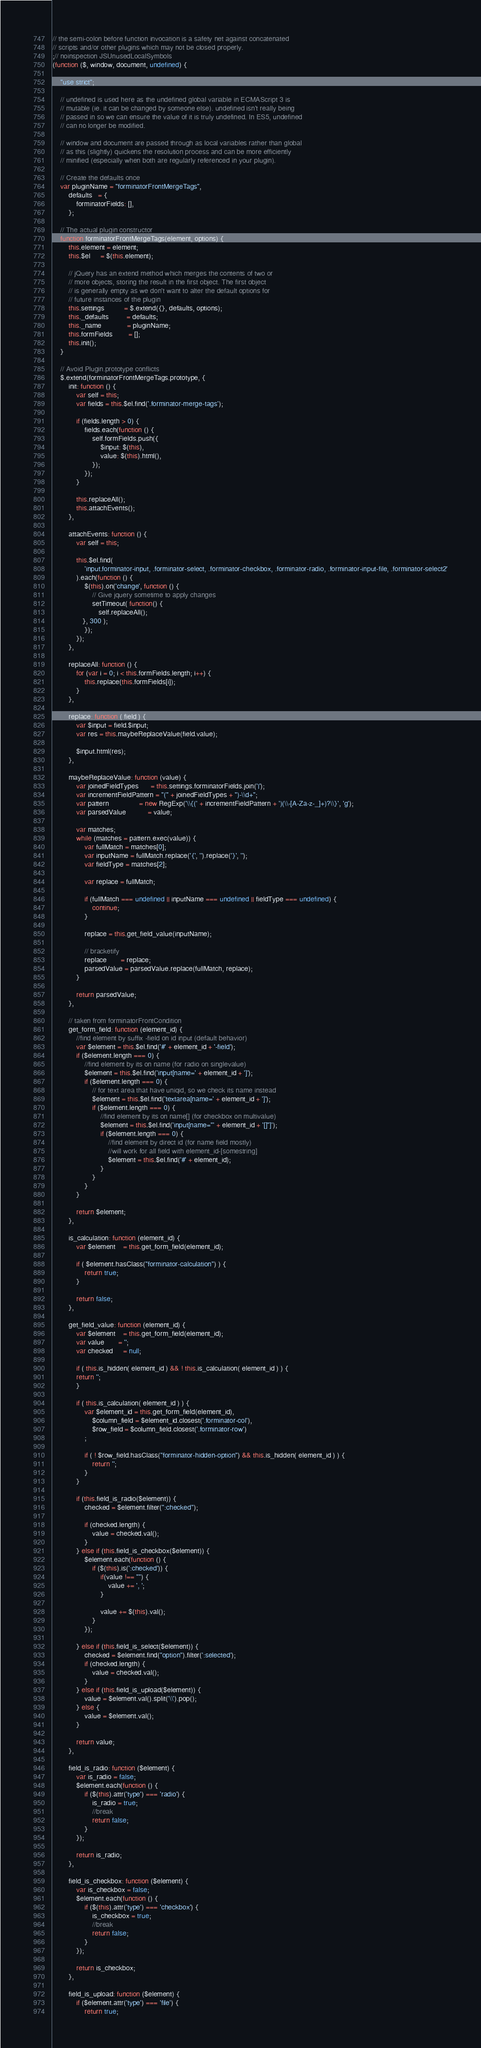Convert code to text. <code><loc_0><loc_0><loc_500><loc_500><_JavaScript_>// the semi-colon before function invocation is a safety net against concatenated
// scripts and/or other plugins which may not be closed properly.
;// noinspection JSUnusedLocalSymbols
(function ($, window, document, undefined) {

	"use strict";

	// undefined is used here as the undefined global variable in ECMAScript 3 is
	// mutable (ie. it can be changed by someone else). undefined isn't really being
	// passed in so we can ensure the value of it is truly undefined. In ES5, undefined
	// can no longer be modified.

	// window and document are passed through as local variables rather than global
	// as this (slightly) quickens the resolution process and can be more efficiently
	// minified (especially when both are regularly referenced in your plugin).

	// Create the defaults once
	var pluginName = "forminatorFrontMergeTags",
	    defaults   = {
		    forminatorFields: [],
	    };

	// The actual plugin constructor
	function forminatorFrontMergeTags(element, options) {
		this.element = element;
		this.$el     = $(this.element);

		// jQuery has an extend method which merges the contents of two or
		// more objects, storing the result in the first object. The first object
		// is generally empty as we don't want to alter the default options for
		// future instances of the plugin
		this.settings          = $.extend({}, defaults, options);
		this._defaults         = defaults;
		this._name             = pluginName;
		this.formFields        = [];
		this.init();
	}

	// Avoid Plugin.prototype conflicts
	$.extend(forminatorFrontMergeTags.prototype, {
		init: function () {
			var self = this;
			var fields = this.$el.find('.forminator-merge-tags');

			if (fields.length > 0) {
				fields.each(function () {
					self.formFields.push({
						$input: $(this),
						value: $(this).html(),
					});
				});
			}

			this.replaceAll();
			this.attachEvents();
		},

		attachEvents: function () {
			var self = this;

			this.$el.find(
				'input.forminator-input, .forminator-select, .forminator-checkbox, .forminator-radio, .forminator-input-file, .forminator-select2'
			).each(function () {
				$(this).on('change', function () {
					// Give jquery sometime to apply changes
					setTimeout( function() {
					   self.replaceAll();
               }, 300 );
				});
			});
		},

		replaceAll: function () {
			for (var i = 0; i < this.formFields.length; i++) {
				this.replace(this.formFields[i]);
			}
		},

		replace: function ( field ) {
			var $input = field.$input;
			var res = this.maybeReplaceValue(field.value);

			$input.html(res);
		},

		maybeReplaceValue: function (value) {
			var joinedFieldTypes      = this.settings.forminatorFields.join('|');
			var incrementFieldPattern = "(" + joinedFieldTypes + ")-\\d+";
			var pattern               = new RegExp('\\{(' + incrementFieldPattern + ')(\\-[A-Za-z-_]+)?\\}', 'g');
			var parsedValue           = value;

			var matches;
			while (matches = pattern.exec(value)) {
				var fullMatch = matches[0];
				var inputName = fullMatch.replace('{', '').replace('}', '');
				var fieldType = matches[2];

				var replace = fullMatch;

				if (fullMatch === undefined || inputName === undefined || fieldType === undefined) {
					continue;
				}

				replace = this.get_field_value(inputName);

				// bracketify
				replace       = replace;
				parsedValue = parsedValue.replace(fullMatch, replace);
			}

			return parsedValue;
		},

		// taken from forminatorFrontCondition
		get_form_field: function (element_id) {
			//find element by suffix -field on id input (default behavior)
			var $element = this.$el.find('#' + element_id + '-field');
			if ($element.length === 0) {
				//find element by its on name (for radio on singlevalue)
				$element = this.$el.find('input[name=' + element_id + ']');
				if ($element.length === 0) {
					// for text area that have uniqid, so we check its name instead
					$element = this.$el.find('textarea[name=' + element_id + ']');
					if ($element.length === 0) {
						//find element by its on name[] (for checkbox on multivalue)
						$element = this.$el.find('input[name="' + element_id + '[]"]');
						if ($element.length === 0) {
							//find element by direct id (for name field mostly)
							//will work for all field with element_id-[somestring]
							$element = this.$el.find('#' + element_id);
						}
					}
				}
			}

			return $element;
		},

		is_calculation: function (element_id) {
			var $element    = this.get_form_field(element_id);

			if ( $element.hasClass("forminator-calculation") ) {
				return true;
			}

			return false;
		},

		get_field_value: function (element_id) {
			var $element    = this.get_form_field(element_id);
			var value       = '';
			var checked     = null;

			if ( this.is_hidden( element_id ) && ! this.is_calculation( element_id ) ) {
         	return '';
			}

			if ( this.is_calculation( element_id ) ) {
				var $element_id = this.get_form_field(element_id),
					$column_field = $element_id.closest('.forminator-col'),
					$row_field = $column_field.closest('.forminator-row')
				;

				if ( ! $row_field.hasClass("forminator-hidden-option") && this.is_hidden( element_id ) ) {
					return '';
				}
			}

			if (this.field_is_radio($element)) {
				checked = $element.filter(":checked");

				if (checked.length) {
					value = checked.val();
				}
			} else if (this.field_is_checkbox($element)) {
				$element.each(function () {
					if ($(this).is(':checked')) {
						if(value !== "") {
							value += ', ';
						}

						value += $(this).val();
					}
				});

			} else if (this.field_is_select($element)) {
				checked = $element.find("option").filter(':selected');
				if (checked.length) {
					value = checked.val();
				}
			} else if (this.field_is_upload($element)) {
				value = $element.val().split('\\').pop();
			} else {
				value = $element.val();
			}

			return value;
		},

		field_is_radio: function ($element) {
			var is_radio = false;
			$element.each(function () {
				if ($(this).attr('type') === 'radio') {
					is_radio = true;
					//break
					return false;
				}
			});

			return is_radio;
		},

		field_is_checkbox: function ($element) {
			var is_checkbox = false;
			$element.each(function () {
				if ($(this).attr('type') === 'checkbox') {
					is_checkbox = true;
					//break
					return false;
				}
			});

			return is_checkbox;
		},

		field_is_upload: function ($element) {
			if ($element.attr('type') === 'file') {
				return true;</code> 